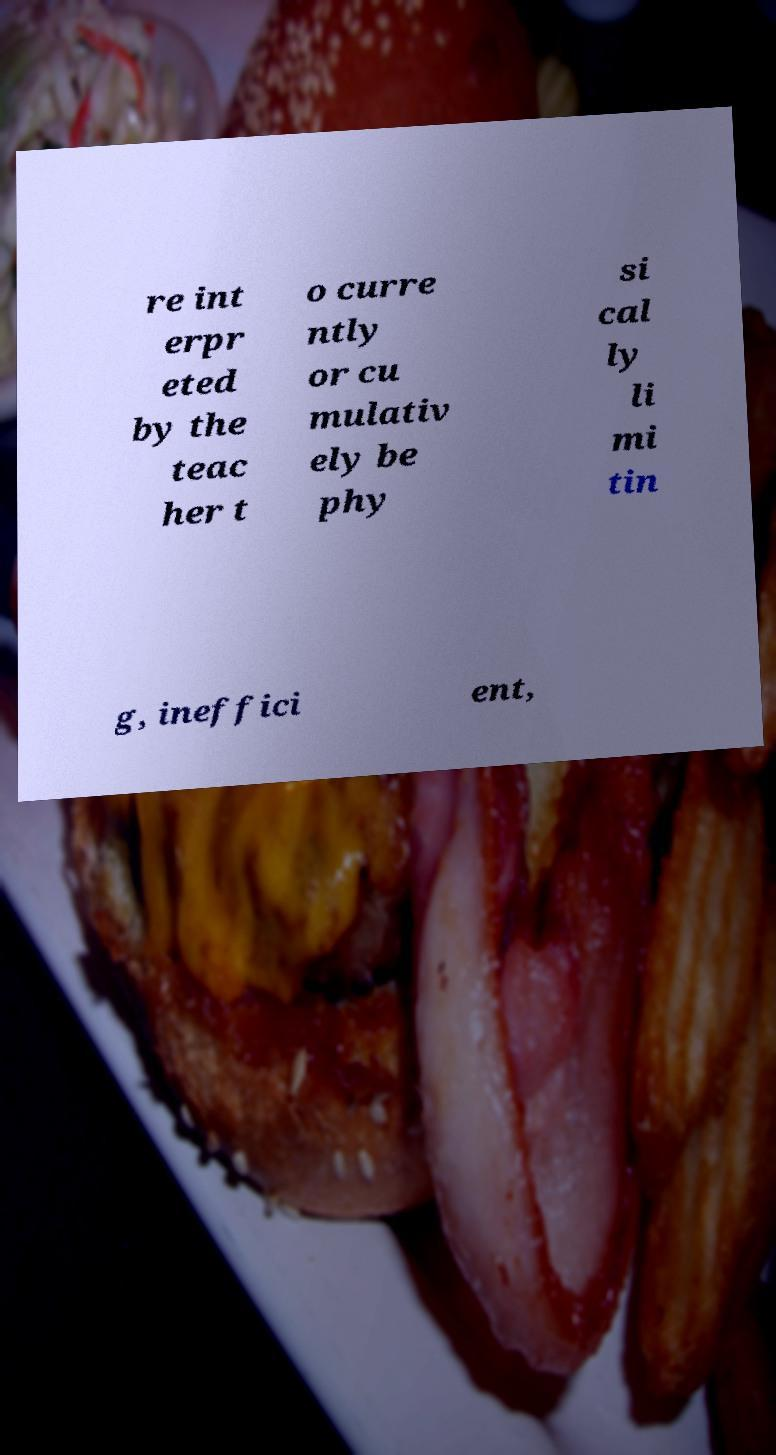Could you extract and type out the text from this image? re int erpr eted by the teac her t o curre ntly or cu mulativ ely be phy si cal ly li mi tin g, ineffici ent, 